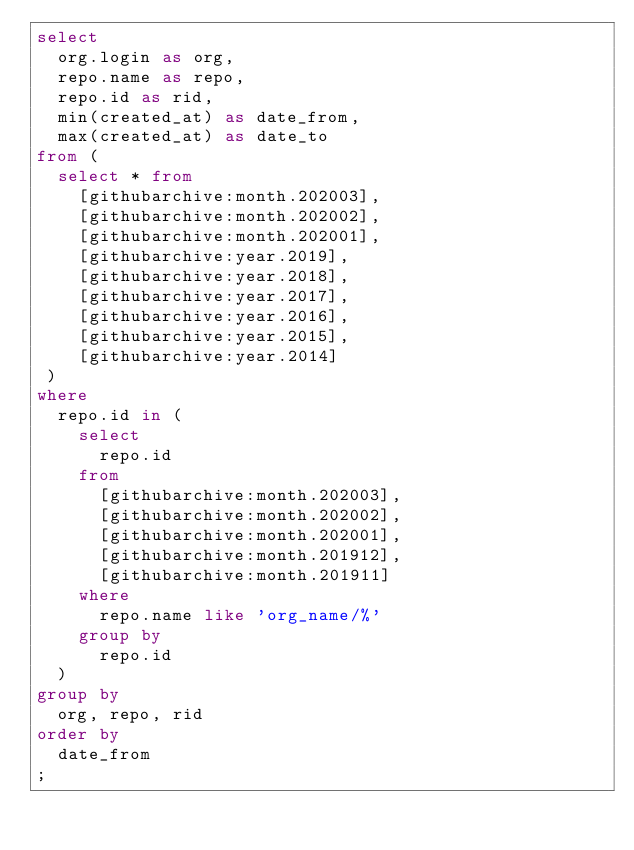Convert code to text. <code><loc_0><loc_0><loc_500><loc_500><_SQL_>select
  org.login as org,
  repo.name as repo,
  repo.id as rid,
  min(created_at) as date_from,
  max(created_at) as date_to
from (
  select * from
    [githubarchive:month.202003],
    [githubarchive:month.202002],
    [githubarchive:month.202001],
    [githubarchive:year.2019],
    [githubarchive:year.2018],
    [githubarchive:year.2017],
    [githubarchive:year.2016],
    [githubarchive:year.2015],
    [githubarchive:year.2014]
 )
where
  repo.id in (
    select
      repo.id
    from
      [githubarchive:month.202003],
      [githubarchive:month.202002],
      [githubarchive:month.202001],
      [githubarchive:month.201912],
      [githubarchive:month.201911]
    where
      repo.name like 'org_name/%'
    group by
      repo.id
  )
group by
  org, repo, rid
order by
  date_from
;
</code> 